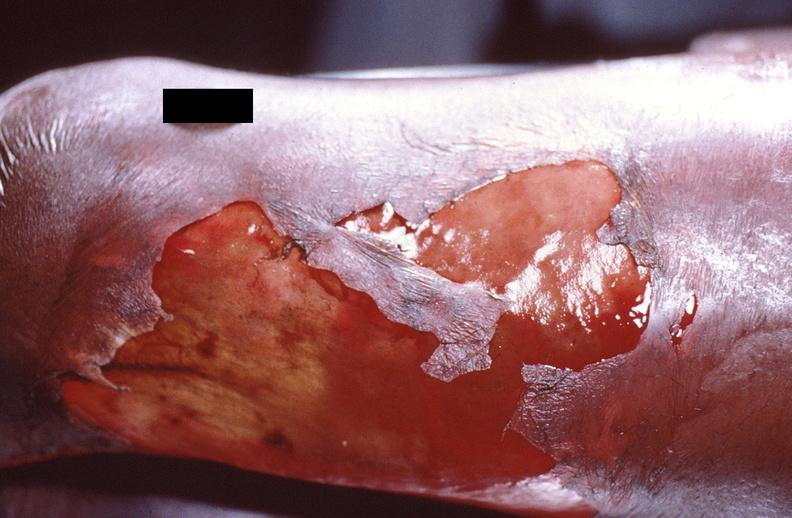what does this image show?
Answer the question using a single word or phrase. Panniculitis and fascitis 